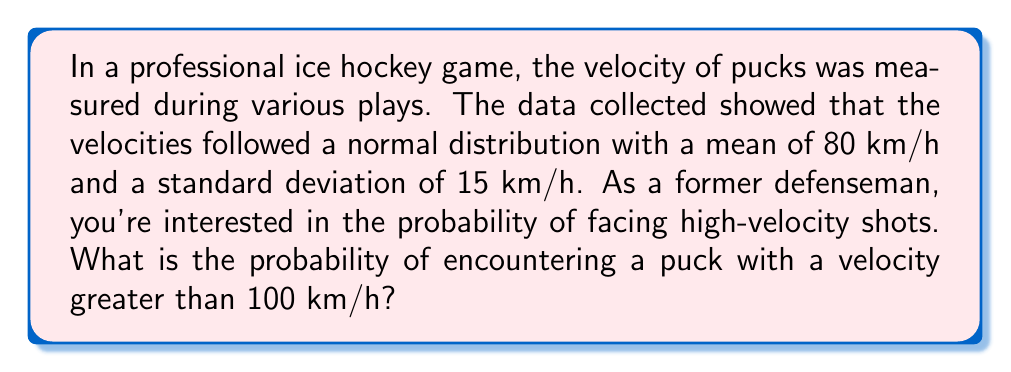Can you answer this question? Let's approach this step-by-step:

1) We're dealing with a normal distribution where:
   $\mu = 80$ km/h (mean)
   $\sigma = 15$ km/h (standard deviation)

2) We want to find $P(X > 100)$, where $X$ is the puck velocity.

3) To use the standard normal distribution, we need to standardize our value:
   
   $z = \frac{x - \mu}{\sigma} = \frac{100 - 80}{15} = \frac{20}{15} \approx 1.33$

4) Now we need to find $P(Z > 1.33)$ where $Z$ is the standard normal variable.

5) Using a standard normal table or calculator, we can find that:
   
   $P(Z < 1.33) \approx 0.9082$

6) Since we want the probability of being greater than 1.33:

   $P(Z > 1.33) = 1 - P(Z < 1.33) = 1 - 0.9082 = 0.0918$

7) Therefore, the probability of encountering a puck with a velocity greater than 100 km/h is approximately 0.0918 or 9.18%.
Answer: 0.0918 or 9.18% 